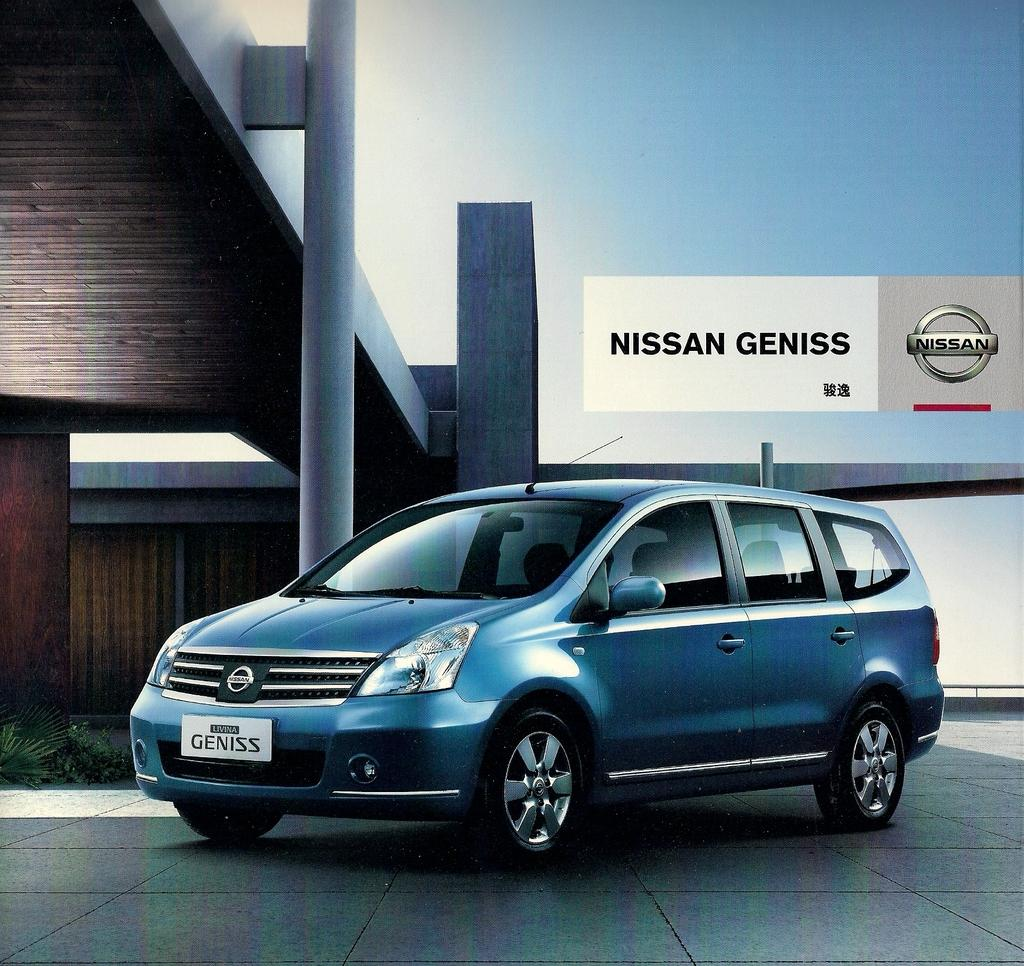What color is the car in the image? The car in the image is blue. Where is the car located in the image? The car is on the road. What is behind the car in the image? There is a building behind the car. What can be seen above the car and building in the image? The sky is visible above the car and building. What type of treatment is being administered to the island in the image? There is no island present in the image, and therefore no treatment can be administered. 